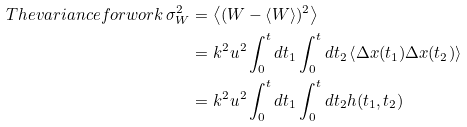Convert formula to latex. <formula><loc_0><loc_0><loc_500><loc_500>T h e v a r i a n c e f o r w o r k \, \sigma _ { W } ^ { 2 } & = \left < ( W - \left < W \right > ) ^ { 2 } \right > \\ & = k ^ { 2 } u ^ { 2 } \int _ { 0 } ^ { t } d t _ { 1 } \int _ { 0 } ^ { t } d t _ { 2 } \left < \Delta x ( t _ { 1 } ) \Delta x ( t _ { 2 } ) \right > \\ & = k ^ { 2 } u ^ { 2 } \int _ { 0 } ^ { t } d t _ { 1 } \int _ { 0 } ^ { t } d t _ { 2 } h ( t _ { 1 } , t _ { 2 } )</formula> 